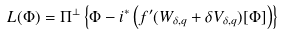Convert formula to latex. <formula><loc_0><loc_0><loc_500><loc_500>L ( \Phi ) = \Pi ^ { \bot } \left \{ \Phi - i ^ { * } \left ( f ^ { \prime } ( W _ { \delta , q } + \delta V _ { \delta , q } ) [ \Phi ] \right ) \right \}</formula> 